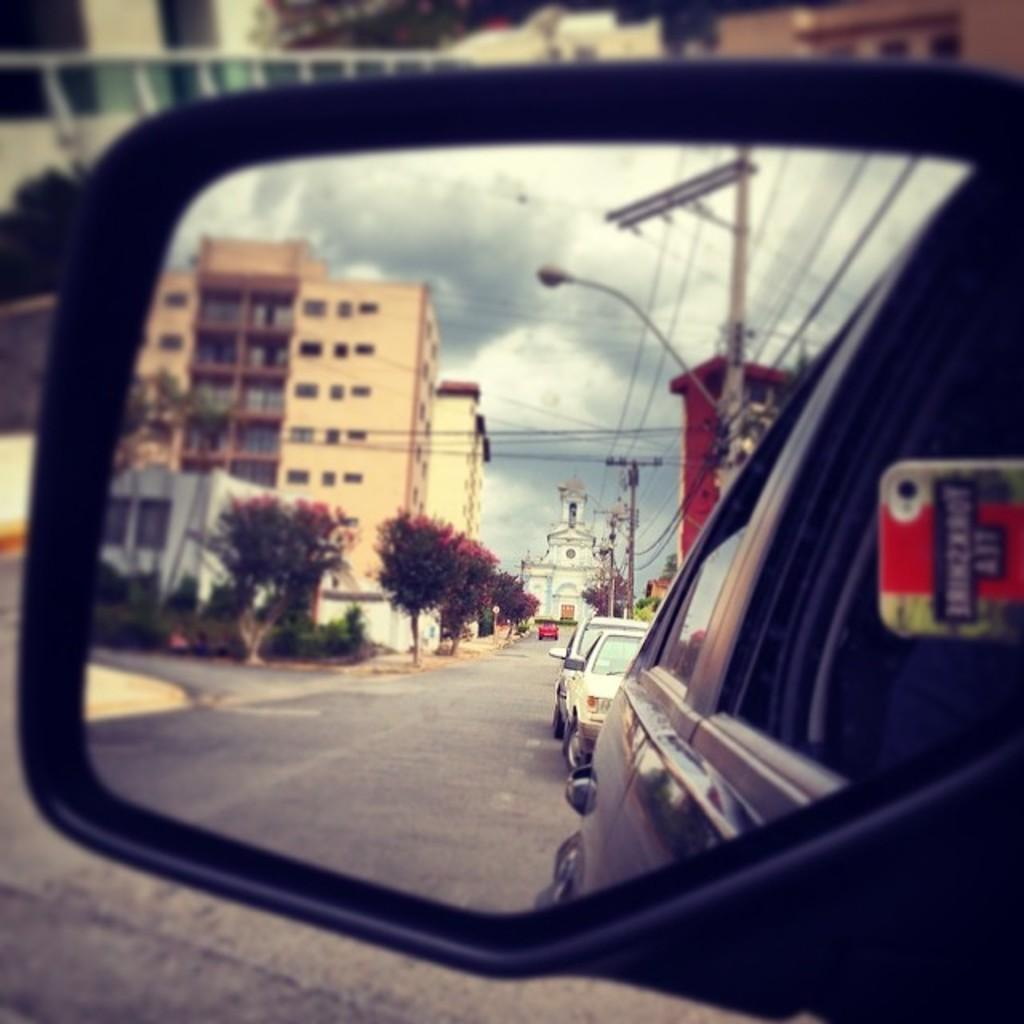What can be seen on the road in the image? There are vehicles on the road in the image. What object is present that can reflect images? The image contains a mirror. What types of objects can be seen in the mirror? Buildings, trees, plants, poles, wires, light, and the sky with clouds are visible in the mirror. How many laborers are folding clothes in the image? There are no laborers or clothes present in the image. What type of sail can be seen in the image? There is no sail present in the image. 